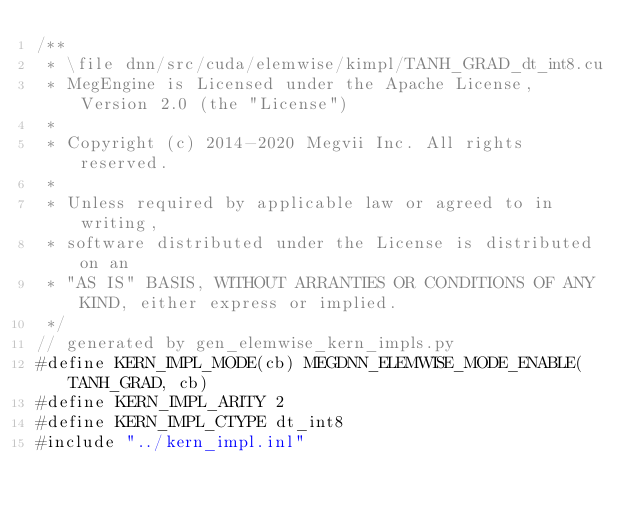<code> <loc_0><loc_0><loc_500><loc_500><_Cuda_>/**
 * \file dnn/src/cuda/elemwise/kimpl/TANH_GRAD_dt_int8.cu
 * MegEngine is Licensed under the Apache License, Version 2.0 (the "License")
 *
 * Copyright (c) 2014-2020 Megvii Inc. All rights reserved.
 *
 * Unless required by applicable law or agreed to in writing,
 * software distributed under the License is distributed on an
 * "AS IS" BASIS, WITHOUT ARRANTIES OR CONDITIONS OF ANY KIND, either express or implied.
 */
// generated by gen_elemwise_kern_impls.py
#define KERN_IMPL_MODE(cb) MEGDNN_ELEMWISE_MODE_ENABLE(TANH_GRAD, cb)
#define KERN_IMPL_ARITY 2
#define KERN_IMPL_CTYPE dt_int8
#include "../kern_impl.inl"
</code> 